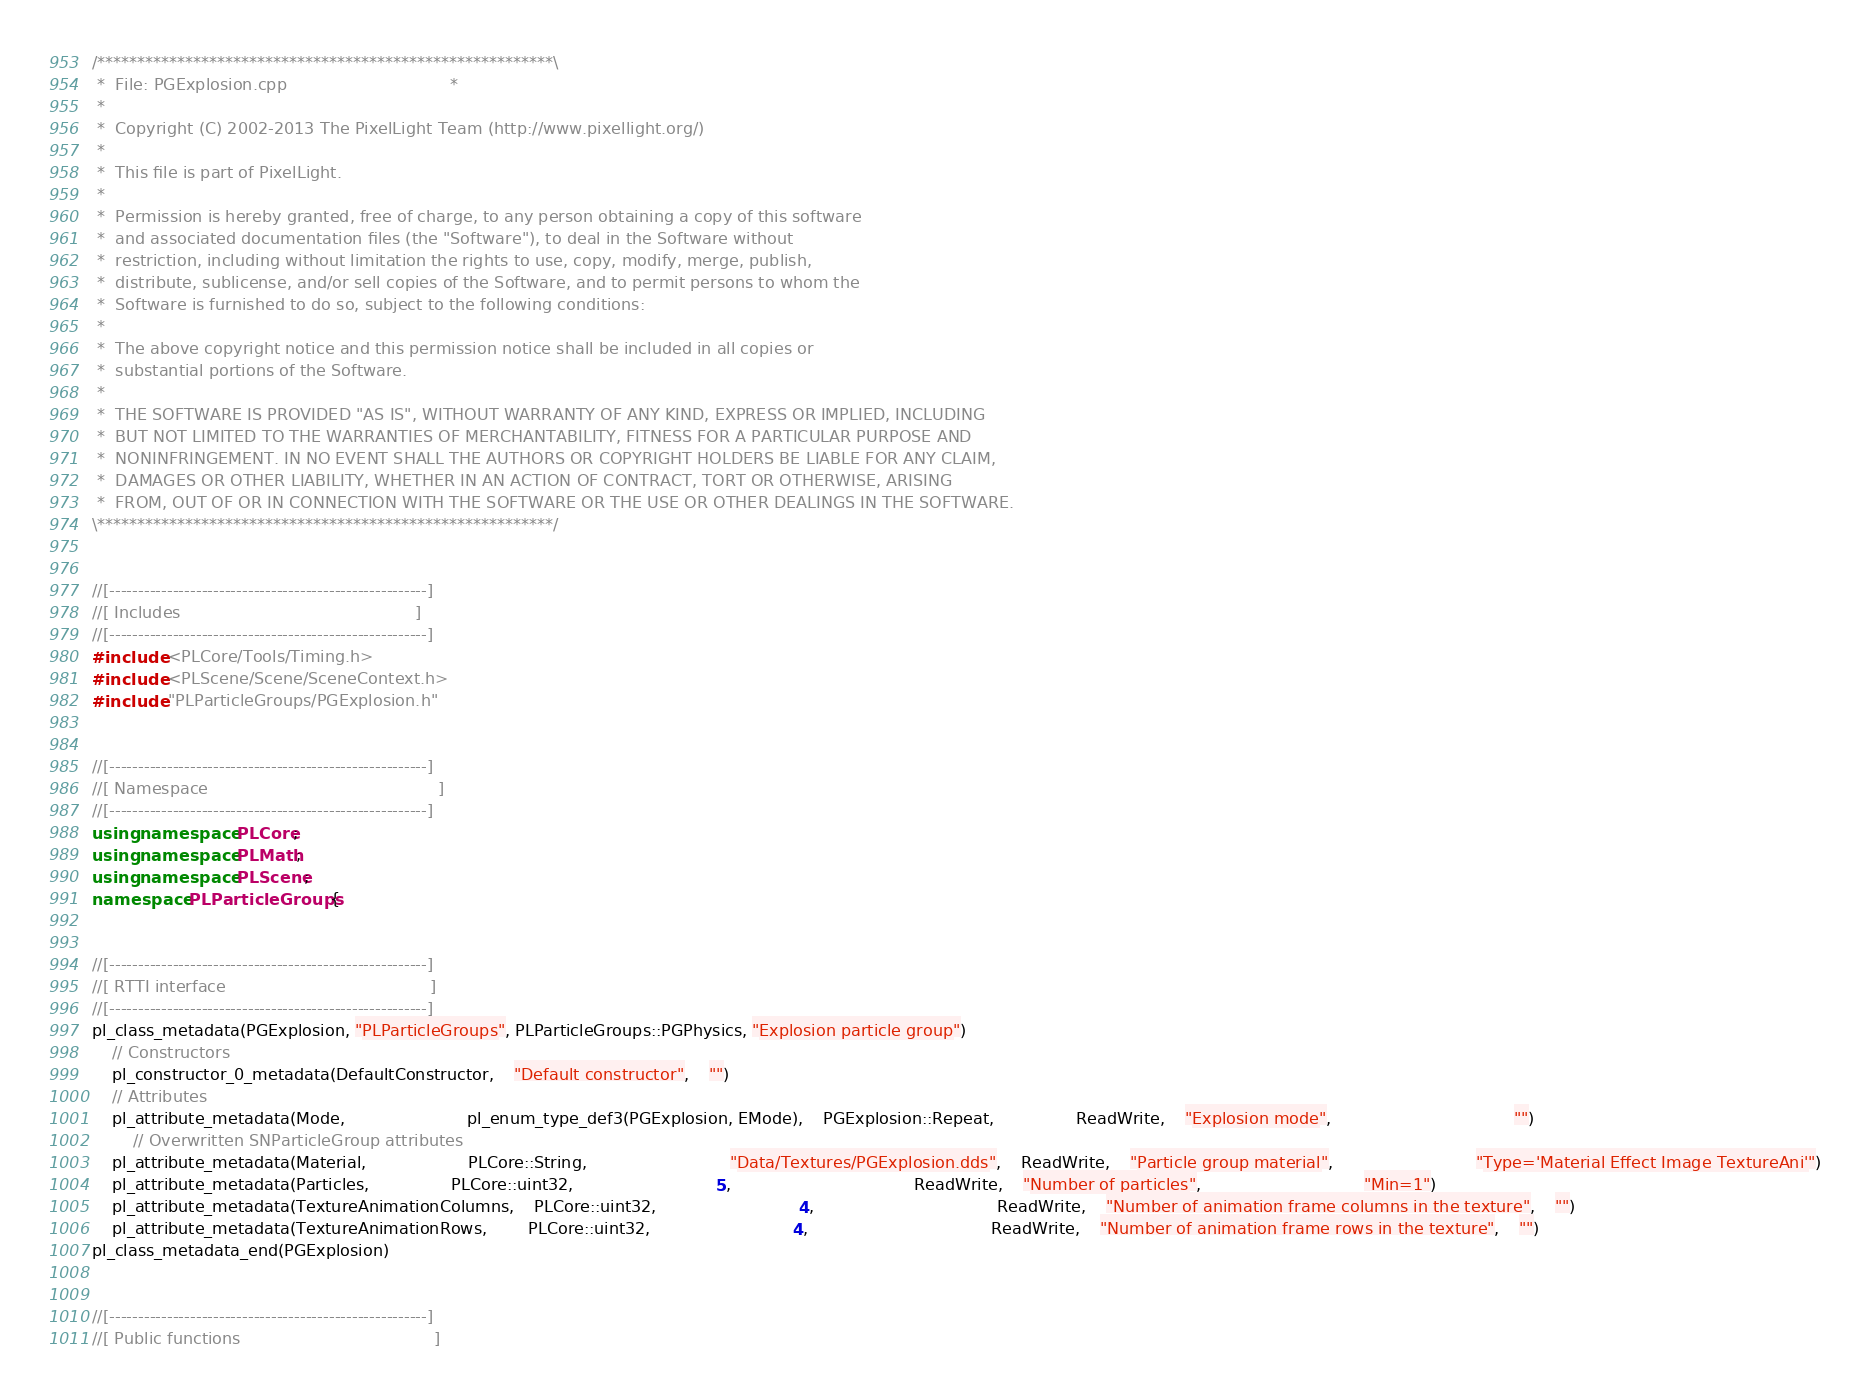<code> <loc_0><loc_0><loc_500><loc_500><_C++_>/*********************************************************\
 *  File: PGExplosion.cpp                                *
 *
 *  Copyright (C) 2002-2013 The PixelLight Team (http://www.pixellight.org/)
 *
 *  This file is part of PixelLight.
 *
 *  Permission is hereby granted, free of charge, to any person obtaining a copy of this software
 *  and associated documentation files (the "Software"), to deal in the Software without
 *  restriction, including without limitation the rights to use, copy, modify, merge, publish,
 *  distribute, sublicense, and/or sell copies of the Software, and to permit persons to whom the
 *  Software is furnished to do so, subject to the following conditions:
 *
 *  The above copyright notice and this permission notice shall be included in all copies or
 *  substantial portions of the Software.
 *
 *  THE SOFTWARE IS PROVIDED "AS IS", WITHOUT WARRANTY OF ANY KIND, EXPRESS OR IMPLIED, INCLUDING
 *  BUT NOT LIMITED TO THE WARRANTIES OF MERCHANTABILITY, FITNESS FOR A PARTICULAR PURPOSE AND
 *  NONINFRINGEMENT. IN NO EVENT SHALL THE AUTHORS OR COPYRIGHT HOLDERS BE LIABLE FOR ANY CLAIM,
 *  DAMAGES OR OTHER LIABILITY, WHETHER IN AN ACTION OF CONTRACT, TORT OR OTHERWISE, ARISING
 *  FROM, OUT OF OR IN CONNECTION WITH THE SOFTWARE OR THE USE OR OTHER DEALINGS IN THE SOFTWARE.
\*********************************************************/


//[-------------------------------------------------------]
//[ Includes                                              ]
//[-------------------------------------------------------]
#include <PLCore/Tools/Timing.h>
#include <PLScene/Scene/SceneContext.h>
#include "PLParticleGroups/PGExplosion.h"


//[-------------------------------------------------------]
//[ Namespace                                             ]
//[-------------------------------------------------------]
using namespace PLCore;
using namespace PLMath;
using namespace PLScene;
namespace PLParticleGroups {


//[-------------------------------------------------------]
//[ RTTI interface                                        ]
//[-------------------------------------------------------]
pl_class_metadata(PGExplosion, "PLParticleGroups", PLParticleGroups::PGPhysics, "Explosion particle group")
	// Constructors
	pl_constructor_0_metadata(DefaultConstructor,	"Default constructor",	"")
	// Attributes
	pl_attribute_metadata(Mode,						pl_enum_type_def3(PGExplosion, EMode),	PGExplosion::Repeat,				ReadWrite,	"Explosion mode",									"")
		// Overwritten SNParticleGroup attributes
	pl_attribute_metadata(Material,					PLCore::String,							"Data/Textures/PGExplosion.dds",	ReadWrite,	"Particle group material",							"Type='Material Effect Image TextureAni'")
	pl_attribute_metadata(Particles,				PLCore::uint32,							5,									ReadWrite,	"Number of particles",								"Min=1")
	pl_attribute_metadata(TextureAnimationColumns,	PLCore::uint32,							4,									ReadWrite,	"Number of animation frame columns in the texture",	"")
	pl_attribute_metadata(TextureAnimationRows,		PLCore::uint32,							4,									ReadWrite,	"Number of animation frame rows in the texture",	"")
pl_class_metadata_end(PGExplosion)


//[-------------------------------------------------------]
//[ Public functions                                      ]</code> 